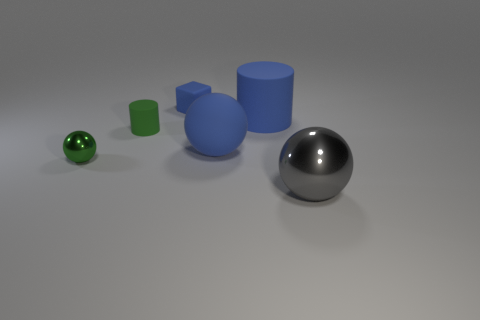There is a object that is the same color as the small metallic sphere; what is its size?
Your answer should be very brief. Small. What shape is the tiny thing that is the same color as the matte ball?
Give a very brief answer. Cube. What number of green cylinders are the same size as the gray shiny sphere?
Your answer should be very brief. 0. What is the color of the thing that is both on the right side of the small blue matte cube and to the left of the blue rubber cylinder?
Provide a short and direct response. Blue. What number of things are blue objects or big matte balls?
Your answer should be compact. 3. What number of tiny things are shiny things or gray balls?
Provide a short and direct response. 1. Is there anything else that is the same color as the block?
Your answer should be very brief. Yes. There is a thing that is in front of the matte sphere and on the left side of the large gray ball; how big is it?
Your answer should be compact. Small. Do the large sphere behind the tiny green metallic object and the sphere on the left side of the big blue rubber ball have the same color?
Your response must be concise. No. What number of other things are made of the same material as the large gray object?
Offer a terse response. 1. 